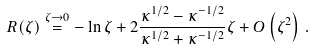Convert formula to latex. <formula><loc_0><loc_0><loc_500><loc_500>R ( \zeta ) \overset { \zeta \rightarrow 0 } { = } - \ln \zeta + 2 \frac { \kappa ^ { 1 / 2 } - \kappa ^ { - 1 / 2 } } { \kappa ^ { 1 / 2 } + \kappa ^ { - 1 / 2 } } \zeta + O \left ( \zeta ^ { 2 } \right ) \, .</formula> 